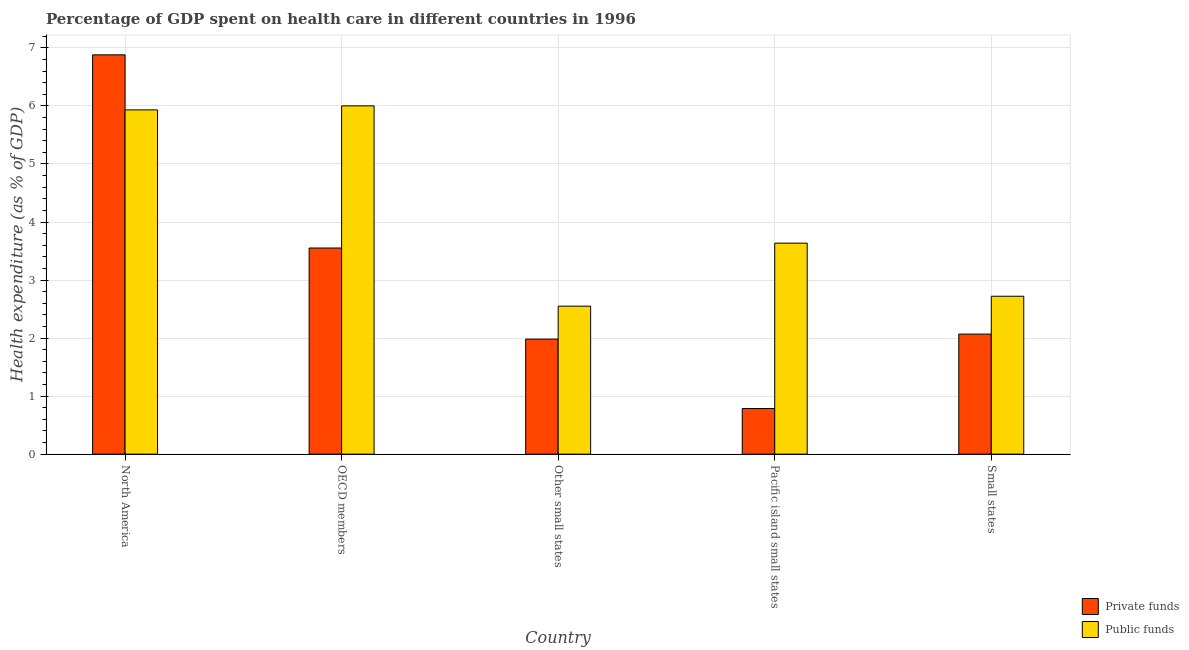How many different coloured bars are there?
Your response must be concise. 2. Are the number of bars on each tick of the X-axis equal?
Your response must be concise. Yes. How many bars are there on the 5th tick from the left?
Offer a terse response. 2. What is the label of the 5th group of bars from the left?
Make the answer very short. Small states. What is the amount of private funds spent in healthcare in Other small states?
Your answer should be compact. 1.98. Across all countries, what is the maximum amount of private funds spent in healthcare?
Keep it short and to the point. 6.88. Across all countries, what is the minimum amount of private funds spent in healthcare?
Provide a short and direct response. 0.79. In which country was the amount of private funds spent in healthcare maximum?
Keep it short and to the point. North America. In which country was the amount of public funds spent in healthcare minimum?
Give a very brief answer. Other small states. What is the total amount of public funds spent in healthcare in the graph?
Provide a short and direct response. 20.84. What is the difference between the amount of public funds spent in healthcare in North America and that in OECD members?
Your answer should be very brief. -0.07. What is the difference between the amount of public funds spent in healthcare in Pacific island small states and the amount of private funds spent in healthcare in Other small states?
Offer a terse response. 1.65. What is the average amount of private funds spent in healthcare per country?
Offer a terse response. 3.05. What is the difference between the amount of private funds spent in healthcare and amount of public funds spent in healthcare in Pacific island small states?
Provide a succinct answer. -2.85. In how many countries, is the amount of public funds spent in healthcare greater than 6.8 %?
Provide a succinct answer. 0. What is the ratio of the amount of private funds spent in healthcare in North America to that in Pacific island small states?
Your response must be concise. 8.75. What is the difference between the highest and the second highest amount of private funds spent in healthcare?
Your answer should be compact. 3.33. What is the difference between the highest and the lowest amount of public funds spent in healthcare?
Ensure brevity in your answer.  3.45. What does the 1st bar from the left in Small states represents?
Give a very brief answer. Private funds. What does the 2nd bar from the right in North America represents?
Keep it short and to the point. Private funds. How many bars are there?
Provide a short and direct response. 10. How many countries are there in the graph?
Make the answer very short. 5. What is the difference between two consecutive major ticks on the Y-axis?
Ensure brevity in your answer.  1. Are the values on the major ticks of Y-axis written in scientific E-notation?
Keep it short and to the point. No. Does the graph contain any zero values?
Keep it short and to the point. No. Does the graph contain grids?
Provide a short and direct response. Yes. Where does the legend appear in the graph?
Provide a succinct answer. Bottom right. How many legend labels are there?
Your answer should be very brief. 2. What is the title of the graph?
Provide a succinct answer. Percentage of GDP spent on health care in different countries in 1996. What is the label or title of the X-axis?
Offer a terse response. Country. What is the label or title of the Y-axis?
Offer a terse response. Health expenditure (as % of GDP). What is the Health expenditure (as % of GDP) in Private funds in North America?
Offer a very short reply. 6.88. What is the Health expenditure (as % of GDP) in Public funds in North America?
Your answer should be compact. 5.93. What is the Health expenditure (as % of GDP) of Private funds in OECD members?
Keep it short and to the point. 3.55. What is the Health expenditure (as % of GDP) of Public funds in OECD members?
Your response must be concise. 6. What is the Health expenditure (as % of GDP) in Private funds in Other small states?
Make the answer very short. 1.98. What is the Health expenditure (as % of GDP) of Public funds in Other small states?
Ensure brevity in your answer.  2.55. What is the Health expenditure (as % of GDP) in Private funds in Pacific island small states?
Offer a very short reply. 0.79. What is the Health expenditure (as % of GDP) of Public funds in Pacific island small states?
Provide a succinct answer. 3.64. What is the Health expenditure (as % of GDP) of Private funds in Small states?
Your answer should be very brief. 2.07. What is the Health expenditure (as % of GDP) of Public funds in Small states?
Your response must be concise. 2.72. Across all countries, what is the maximum Health expenditure (as % of GDP) in Private funds?
Ensure brevity in your answer.  6.88. Across all countries, what is the maximum Health expenditure (as % of GDP) in Public funds?
Offer a very short reply. 6. Across all countries, what is the minimum Health expenditure (as % of GDP) in Private funds?
Ensure brevity in your answer.  0.79. Across all countries, what is the minimum Health expenditure (as % of GDP) in Public funds?
Ensure brevity in your answer.  2.55. What is the total Health expenditure (as % of GDP) of Private funds in the graph?
Make the answer very short. 15.27. What is the total Health expenditure (as % of GDP) in Public funds in the graph?
Your response must be concise. 20.84. What is the difference between the Health expenditure (as % of GDP) of Private funds in North America and that in OECD members?
Your response must be concise. 3.33. What is the difference between the Health expenditure (as % of GDP) in Public funds in North America and that in OECD members?
Your answer should be very brief. -0.07. What is the difference between the Health expenditure (as % of GDP) in Private funds in North America and that in Other small states?
Give a very brief answer. 4.9. What is the difference between the Health expenditure (as % of GDP) in Public funds in North America and that in Other small states?
Make the answer very short. 3.38. What is the difference between the Health expenditure (as % of GDP) of Private funds in North America and that in Pacific island small states?
Give a very brief answer. 6.09. What is the difference between the Health expenditure (as % of GDP) in Public funds in North America and that in Pacific island small states?
Offer a terse response. 2.3. What is the difference between the Health expenditure (as % of GDP) of Private funds in North America and that in Small states?
Keep it short and to the point. 4.81. What is the difference between the Health expenditure (as % of GDP) in Public funds in North America and that in Small states?
Ensure brevity in your answer.  3.21. What is the difference between the Health expenditure (as % of GDP) in Private funds in OECD members and that in Other small states?
Your answer should be compact. 1.57. What is the difference between the Health expenditure (as % of GDP) in Public funds in OECD members and that in Other small states?
Give a very brief answer. 3.45. What is the difference between the Health expenditure (as % of GDP) in Private funds in OECD members and that in Pacific island small states?
Keep it short and to the point. 2.77. What is the difference between the Health expenditure (as % of GDP) in Public funds in OECD members and that in Pacific island small states?
Offer a terse response. 2.37. What is the difference between the Health expenditure (as % of GDP) in Private funds in OECD members and that in Small states?
Provide a succinct answer. 1.48. What is the difference between the Health expenditure (as % of GDP) of Public funds in OECD members and that in Small states?
Your answer should be very brief. 3.28. What is the difference between the Health expenditure (as % of GDP) of Private funds in Other small states and that in Pacific island small states?
Your response must be concise. 1.2. What is the difference between the Health expenditure (as % of GDP) of Public funds in Other small states and that in Pacific island small states?
Your answer should be very brief. -1.09. What is the difference between the Health expenditure (as % of GDP) in Private funds in Other small states and that in Small states?
Offer a very short reply. -0.09. What is the difference between the Health expenditure (as % of GDP) in Public funds in Other small states and that in Small states?
Your response must be concise. -0.17. What is the difference between the Health expenditure (as % of GDP) in Private funds in Pacific island small states and that in Small states?
Offer a terse response. -1.28. What is the difference between the Health expenditure (as % of GDP) in Public funds in Pacific island small states and that in Small states?
Your response must be concise. 0.92. What is the difference between the Health expenditure (as % of GDP) in Private funds in North America and the Health expenditure (as % of GDP) in Public funds in OECD members?
Offer a terse response. 0.88. What is the difference between the Health expenditure (as % of GDP) in Private funds in North America and the Health expenditure (as % of GDP) in Public funds in Other small states?
Make the answer very short. 4.33. What is the difference between the Health expenditure (as % of GDP) of Private funds in North America and the Health expenditure (as % of GDP) of Public funds in Pacific island small states?
Your response must be concise. 3.24. What is the difference between the Health expenditure (as % of GDP) of Private funds in North America and the Health expenditure (as % of GDP) of Public funds in Small states?
Give a very brief answer. 4.16. What is the difference between the Health expenditure (as % of GDP) of Private funds in OECD members and the Health expenditure (as % of GDP) of Public funds in Other small states?
Provide a succinct answer. 1. What is the difference between the Health expenditure (as % of GDP) of Private funds in OECD members and the Health expenditure (as % of GDP) of Public funds in Pacific island small states?
Make the answer very short. -0.08. What is the difference between the Health expenditure (as % of GDP) in Private funds in OECD members and the Health expenditure (as % of GDP) in Public funds in Small states?
Make the answer very short. 0.83. What is the difference between the Health expenditure (as % of GDP) in Private funds in Other small states and the Health expenditure (as % of GDP) in Public funds in Pacific island small states?
Provide a succinct answer. -1.65. What is the difference between the Health expenditure (as % of GDP) in Private funds in Other small states and the Health expenditure (as % of GDP) in Public funds in Small states?
Your response must be concise. -0.74. What is the difference between the Health expenditure (as % of GDP) of Private funds in Pacific island small states and the Health expenditure (as % of GDP) of Public funds in Small states?
Provide a short and direct response. -1.93. What is the average Health expenditure (as % of GDP) in Private funds per country?
Offer a terse response. 3.05. What is the average Health expenditure (as % of GDP) in Public funds per country?
Your answer should be compact. 4.17. What is the difference between the Health expenditure (as % of GDP) of Private funds and Health expenditure (as % of GDP) of Public funds in North America?
Ensure brevity in your answer.  0.95. What is the difference between the Health expenditure (as % of GDP) of Private funds and Health expenditure (as % of GDP) of Public funds in OECD members?
Give a very brief answer. -2.45. What is the difference between the Health expenditure (as % of GDP) in Private funds and Health expenditure (as % of GDP) in Public funds in Other small states?
Your response must be concise. -0.57. What is the difference between the Health expenditure (as % of GDP) in Private funds and Health expenditure (as % of GDP) in Public funds in Pacific island small states?
Your response must be concise. -2.85. What is the difference between the Health expenditure (as % of GDP) of Private funds and Health expenditure (as % of GDP) of Public funds in Small states?
Provide a succinct answer. -0.65. What is the ratio of the Health expenditure (as % of GDP) of Private funds in North America to that in OECD members?
Your answer should be compact. 1.94. What is the ratio of the Health expenditure (as % of GDP) of Public funds in North America to that in OECD members?
Offer a very short reply. 0.99. What is the ratio of the Health expenditure (as % of GDP) in Private funds in North America to that in Other small states?
Your answer should be compact. 3.47. What is the ratio of the Health expenditure (as % of GDP) in Public funds in North America to that in Other small states?
Offer a very short reply. 2.33. What is the ratio of the Health expenditure (as % of GDP) of Private funds in North America to that in Pacific island small states?
Your answer should be compact. 8.75. What is the ratio of the Health expenditure (as % of GDP) in Public funds in North America to that in Pacific island small states?
Give a very brief answer. 1.63. What is the ratio of the Health expenditure (as % of GDP) of Private funds in North America to that in Small states?
Give a very brief answer. 3.33. What is the ratio of the Health expenditure (as % of GDP) of Public funds in North America to that in Small states?
Give a very brief answer. 2.18. What is the ratio of the Health expenditure (as % of GDP) in Private funds in OECD members to that in Other small states?
Offer a terse response. 1.79. What is the ratio of the Health expenditure (as % of GDP) of Public funds in OECD members to that in Other small states?
Ensure brevity in your answer.  2.35. What is the ratio of the Health expenditure (as % of GDP) in Private funds in OECD members to that in Pacific island small states?
Make the answer very short. 4.52. What is the ratio of the Health expenditure (as % of GDP) in Public funds in OECD members to that in Pacific island small states?
Your answer should be very brief. 1.65. What is the ratio of the Health expenditure (as % of GDP) in Private funds in OECD members to that in Small states?
Make the answer very short. 1.72. What is the ratio of the Health expenditure (as % of GDP) in Public funds in OECD members to that in Small states?
Offer a very short reply. 2.21. What is the ratio of the Health expenditure (as % of GDP) of Private funds in Other small states to that in Pacific island small states?
Give a very brief answer. 2.52. What is the ratio of the Health expenditure (as % of GDP) of Public funds in Other small states to that in Pacific island small states?
Your response must be concise. 0.7. What is the ratio of the Health expenditure (as % of GDP) in Public funds in Other small states to that in Small states?
Your response must be concise. 0.94. What is the ratio of the Health expenditure (as % of GDP) of Private funds in Pacific island small states to that in Small states?
Your response must be concise. 0.38. What is the ratio of the Health expenditure (as % of GDP) of Public funds in Pacific island small states to that in Small states?
Your response must be concise. 1.34. What is the difference between the highest and the second highest Health expenditure (as % of GDP) of Private funds?
Give a very brief answer. 3.33. What is the difference between the highest and the second highest Health expenditure (as % of GDP) in Public funds?
Ensure brevity in your answer.  0.07. What is the difference between the highest and the lowest Health expenditure (as % of GDP) in Private funds?
Give a very brief answer. 6.09. What is the difference between the highest and the lowest Health expenditure (as % of GDP) in Public funds?
Give a very brief answer. 3.45. 